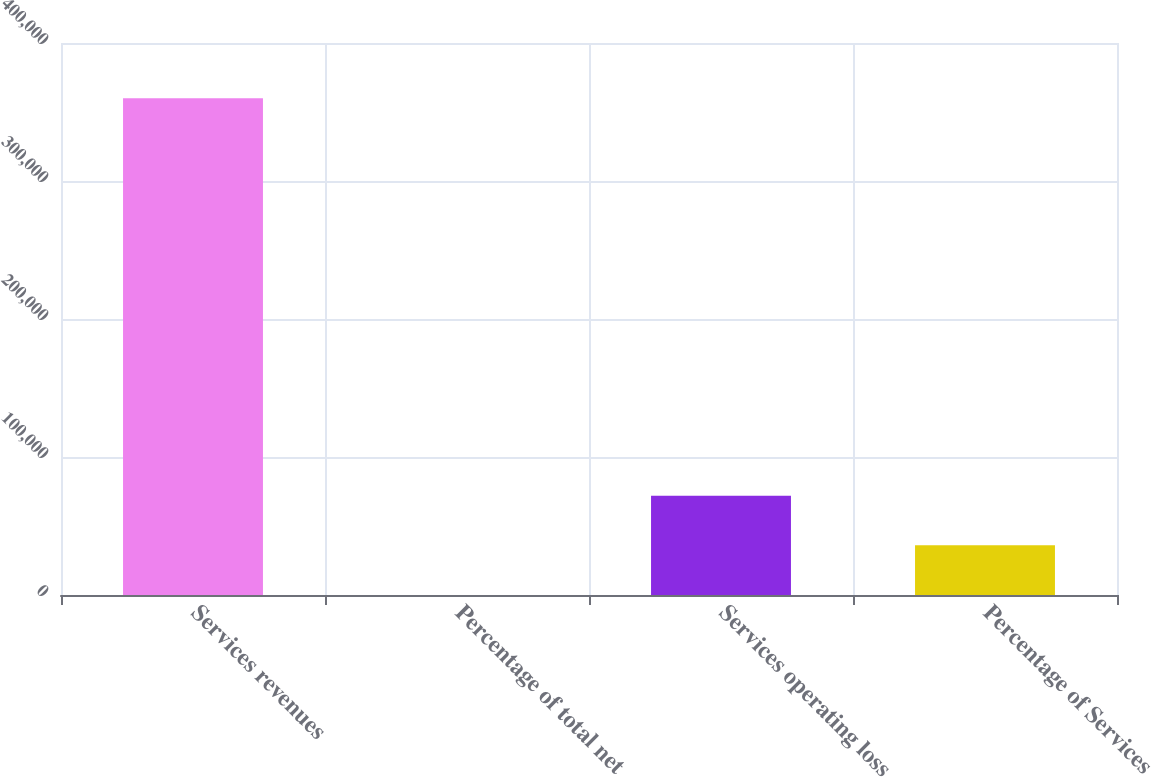Convert chart. <chart><loc_0><loc_0><loc_500><loc_500><bar_chart><fcel>Services revenues<fcel>Percentage of total net<fcel>Services operating loss<fcel>Percentage of Services<nl><fcel>359955<fcel>6<fcel>71995.8<fcel>36000.9<nl></chart> 